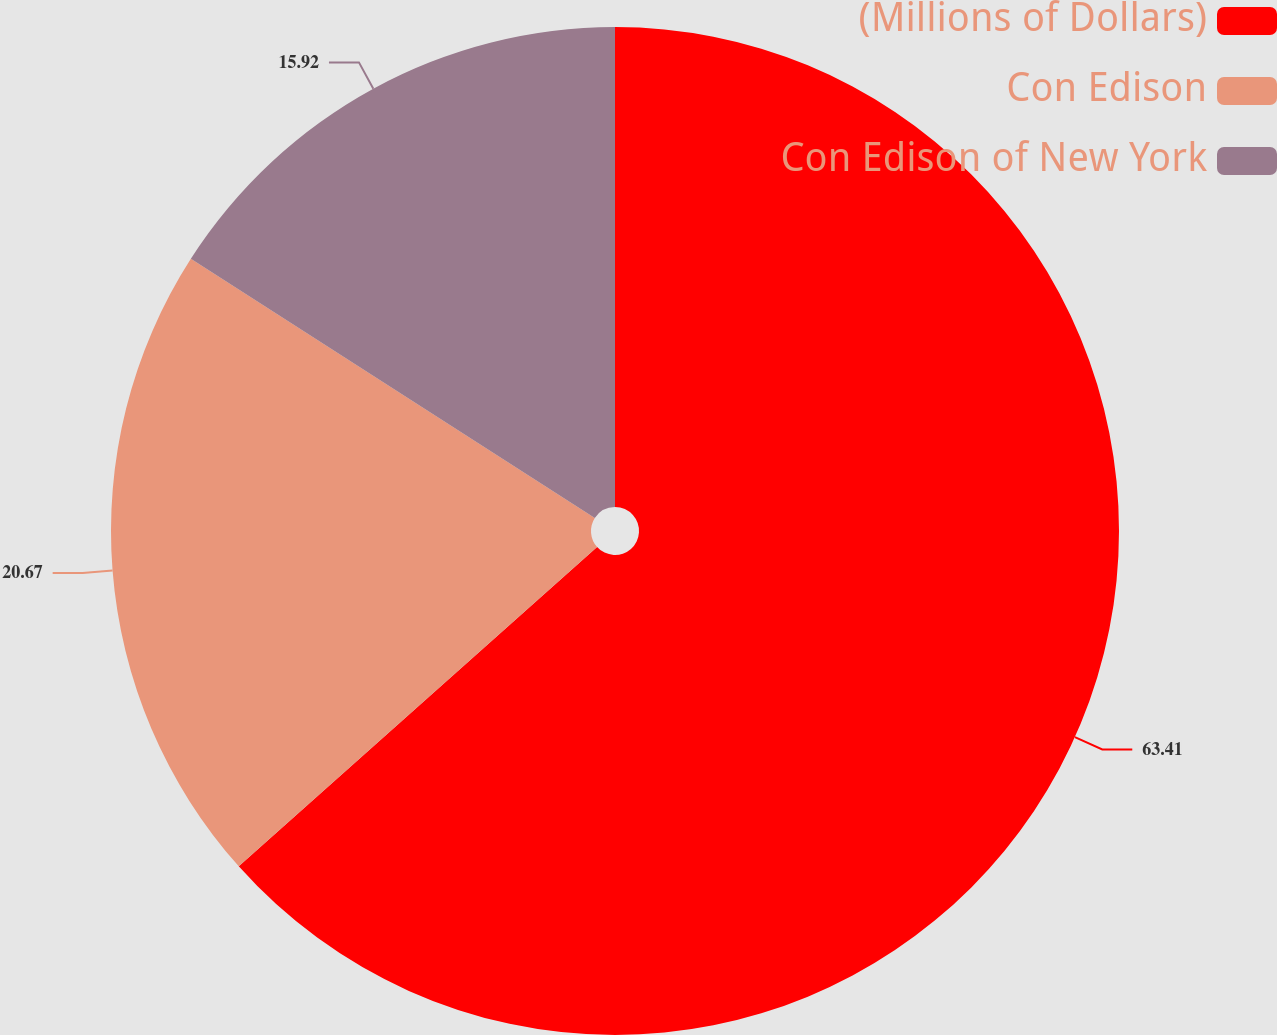Convert chart to OTSL. <chart><loc_0><loc_0><loc_500><loc_500><pie_chart><fcel>(Millions of Dollars)<fcel>Con Edison<fcel>Con Edison of New York<nl><fcel>63.42%<fcel>20.67%<fcel>15.92%<nl></chart> 